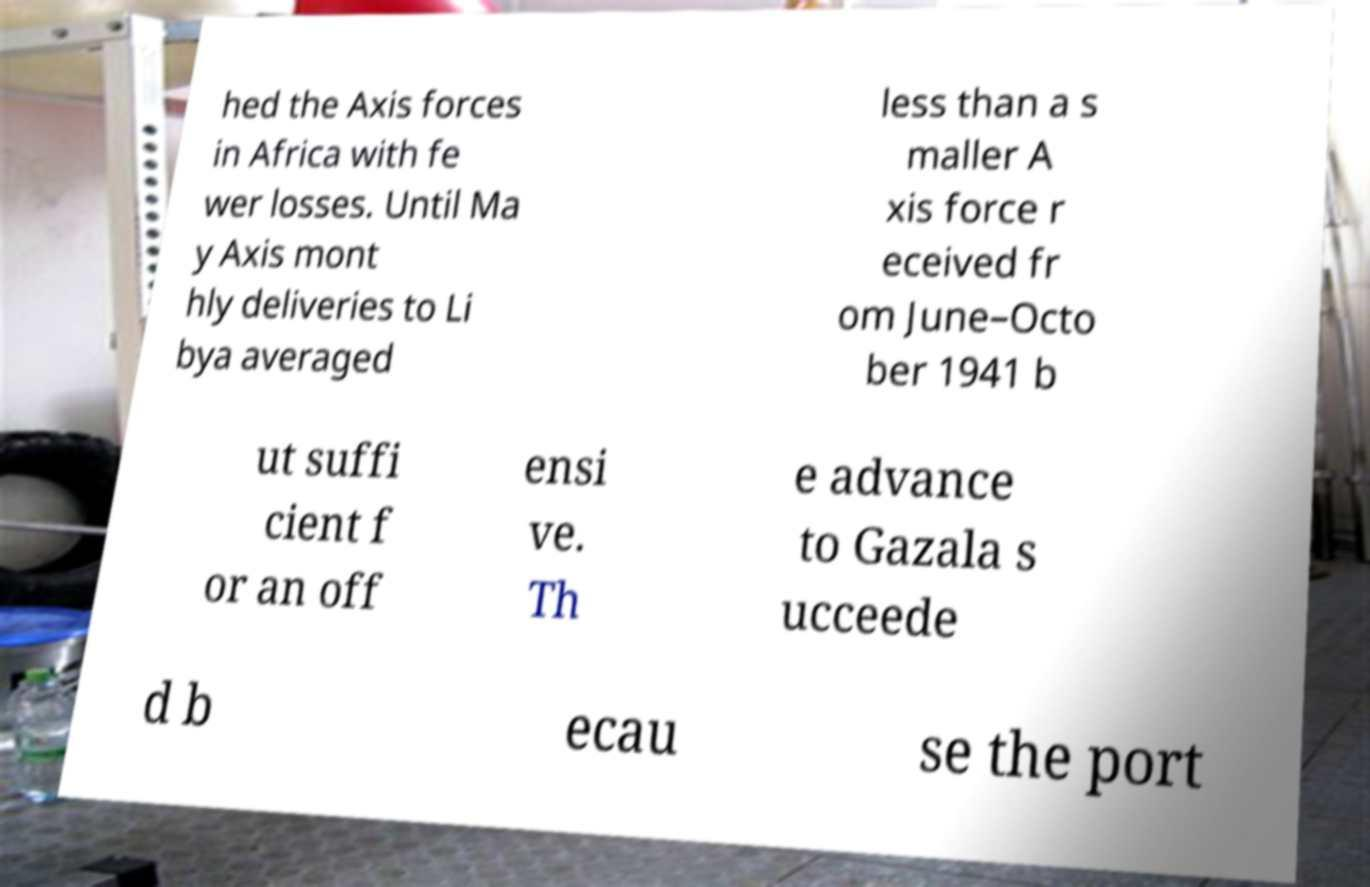Could you extract and type out the text from this image? hed the Axis forces in Africa with fe wer losses. Until Ma y Axis mont hly deliveries to Li bya averaged less than a s maller A xis force r eceived fr om June–Octo ber 1941 b ut suffi cient f or an off ensi ve. Th e advance to Gazala s ucceede d b ecau se the port 